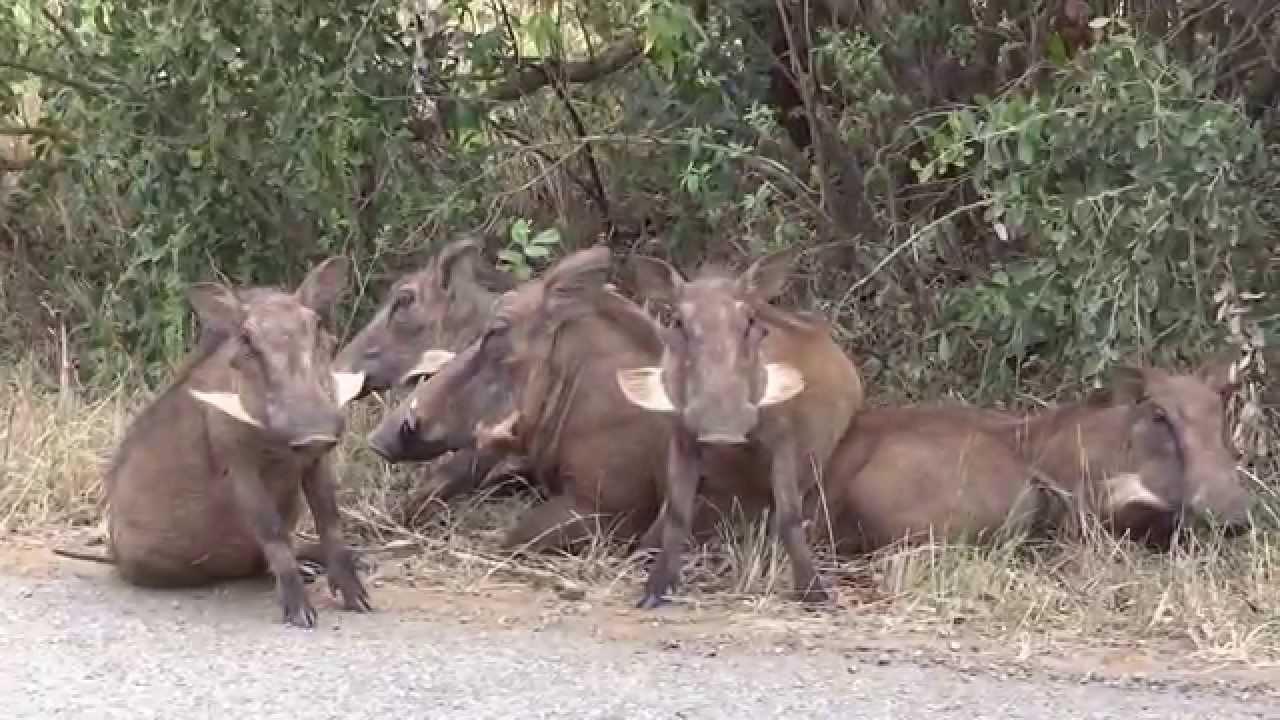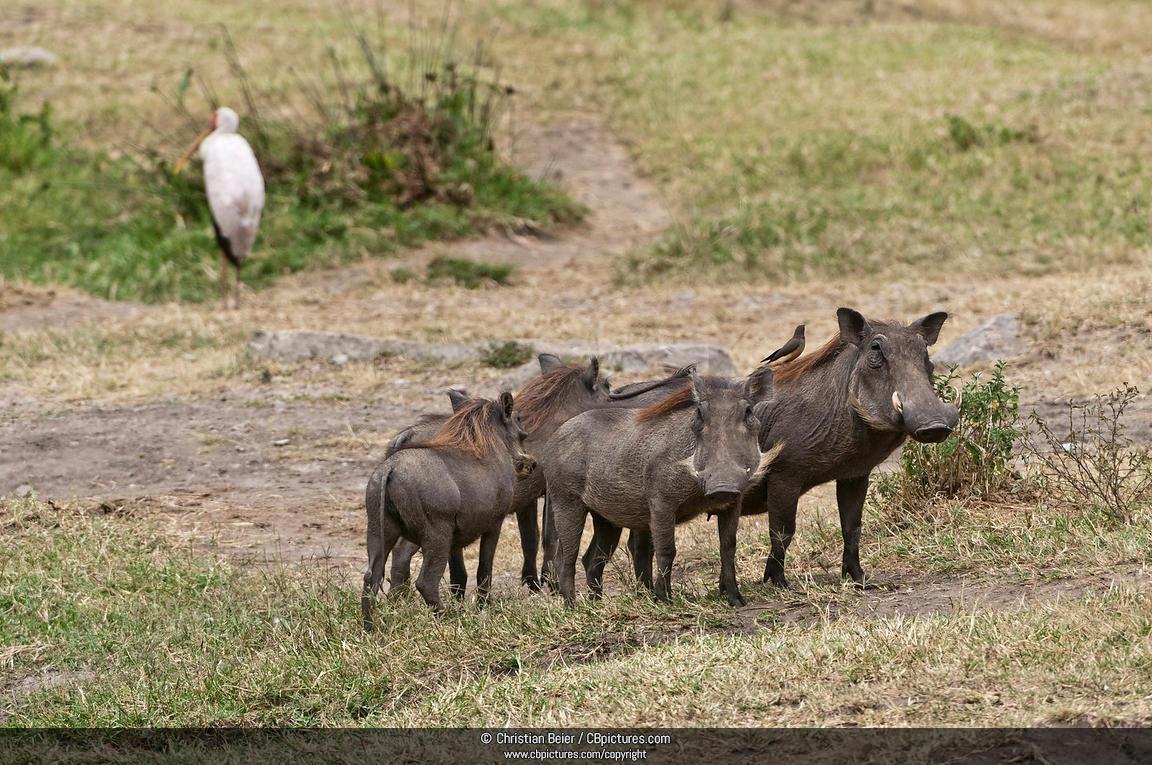The first image is the image on the left, the second image is the image on the right. Examine the images to the left and right. Is the description "An image shows a warthog sitting upright, with multiple hogs behind it." accurate? Answer yes or no. Yes. 